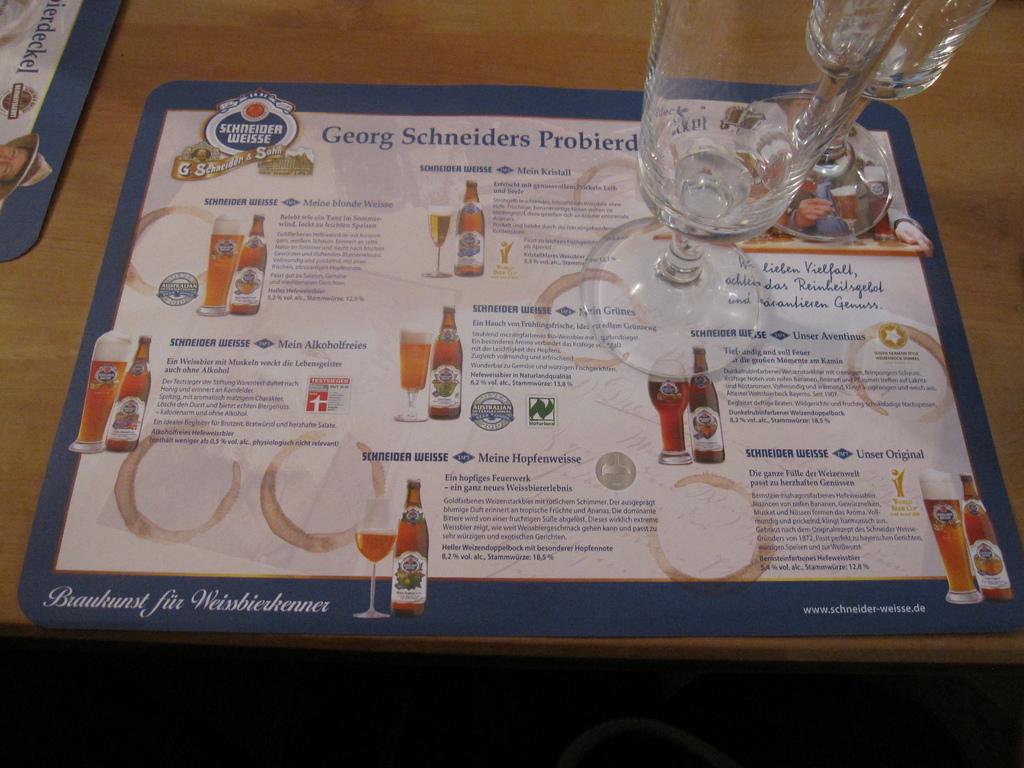What is the brand of alcohol?
Give a very brief answer. Schneider weisse. 